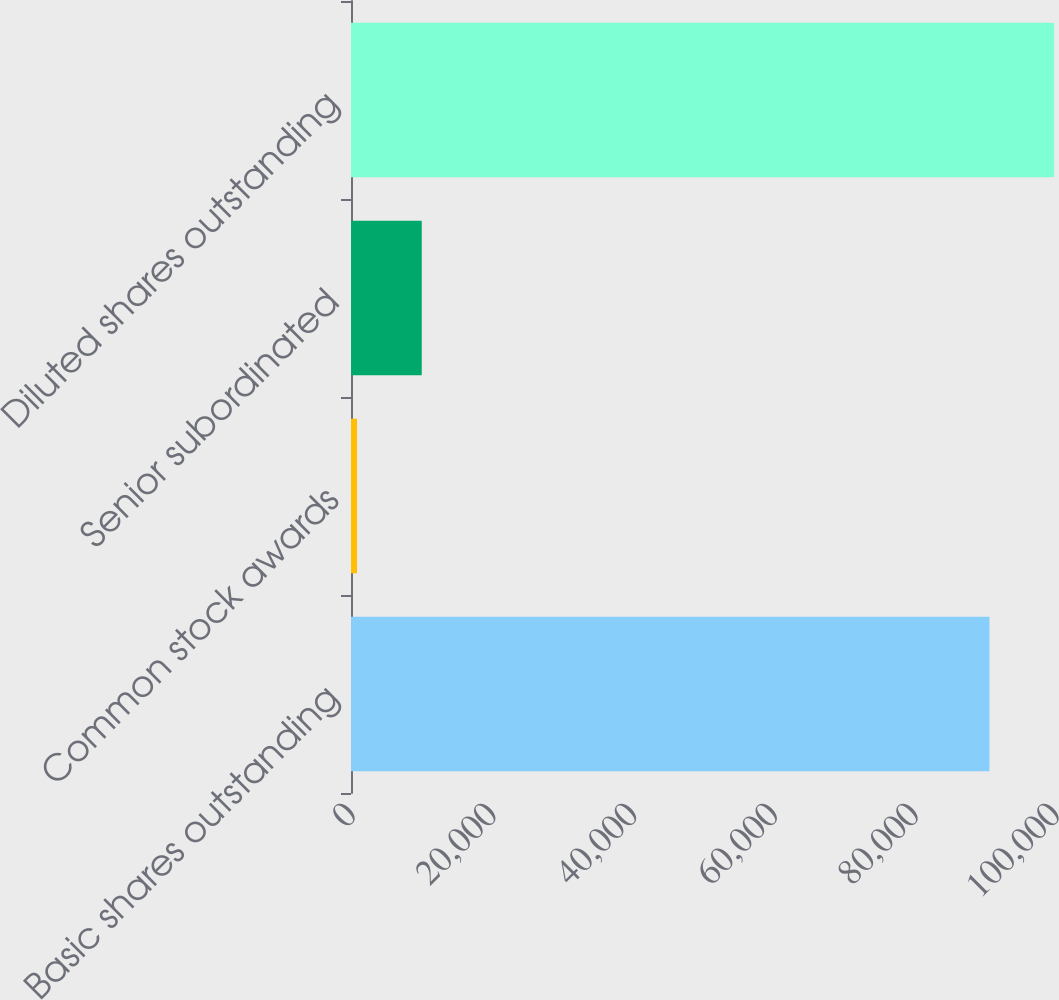Convert chart. <chart><loc_0><loc_0><loc_500><loc_500><bar_chart><fcel>Basic shares outstanding<fcel>Common stock awards<fcel>Senior subordinated<fcel>Diluted shares outstanding<nl><fcel>90685<fcel>853<fcel>10049.7<fcel>99881.7<nl></chart> 